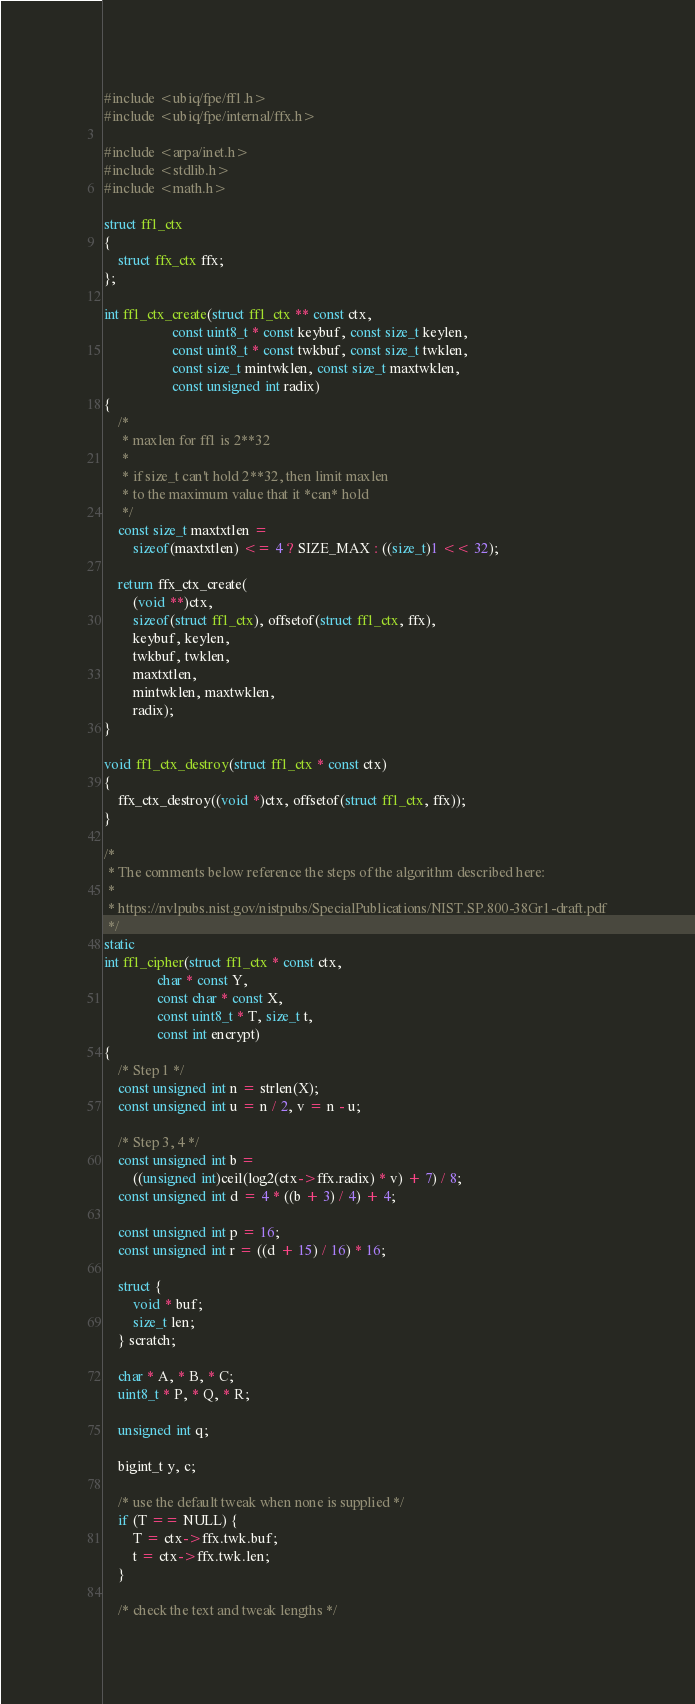<code> <loc_0><loc_0><loc_500><loc_500><_C_>#include <ubiq/fpe/ff1.h>
#include <ubiq/fpe/internal/ffx.h>

#include <arpa/inet.h>
#include <stdlib.h>
#include <math.h>

struct ff1_ctx
{
    struct ffx_ctx ffx;
};

int ff1_ctx_create(struct ff1_ctx ** const ctx,
                   const uint8_t * const keybuf, const size_t keylen,
                   const uint8_t * const twkbuf, const size_t twklen,
                   const size_t mintwklen, const size_t maxtwklen,
                   const unsigned int radix)
{
    /*
     * maxlen for ff1 is 2**32
     *
     * if size_t can't hold 2**32, then limit maxlen
     * to the maximum value that it *can* hold
     */
    const size_t maxtxtlen =
        sizeof(maxtxtlen) <= 4 ? SIZE_MAX : ((size_t)1 << 32);

    return ffx_ctx_create(
        (void **)ctx,
        sizeof(struct ff1_ctx), offsetof(struct ff1_ctx, ffx),
        keybuf, keylen,
        twkbuf, twklen,
        maxtxtlen,
        mintwklen, maxtwklen,
        radix);
}

void ff1_ctx_destroy(struct ff1_ctx * const ctx)
{
    ffx_ctx_destroy((void *)ctx, offsetof(struct ff1_ctx, ffx));
}

/*
 * The comments below reference the steps of the algorithm described here:
 *
 * https://nvlpubs.nist.gov/nistpubs/SpecialPublications/NIST.SP.800-38Gr1-draft.pdf
 */
static
int ff1_cipher(struct ff1_ctx * const ctx,
               char * const Y,
               const char * const X,
               const uint8_t * T, size_t t,
               const int encrypt)
{
    /* Step 1 */
    const unsigned int n = strlen(X);
    const unsigned int u = n / 2, v = n - u;

    /* Step 3, 4 */
    const unsigned int b =
        ((unsigned int)ceil(log2(ctx->ffx.radix) * v) + 7) / 8;
    const unsigned int d = 4 * ((b + 3) / 4) + 4;

    const unsigned int p = 16;
    const unsigned int r = ((d + 15) / 16) * 16;

    struct {
        void * buf;
        size_t len;
    } scratch;

    char * A, * B, * C;
    uint8_t * P, * Q, * R;

    unsigned int q;

    bigint_t y, c;

    /* use the default tweak when none is supplied */
    if (T == NULL) {
        T = ctx->ffx.twk.buf;
        t = ctx->ffx.twk.len;
    }

    /* check the text and tweak lengths */</code> 